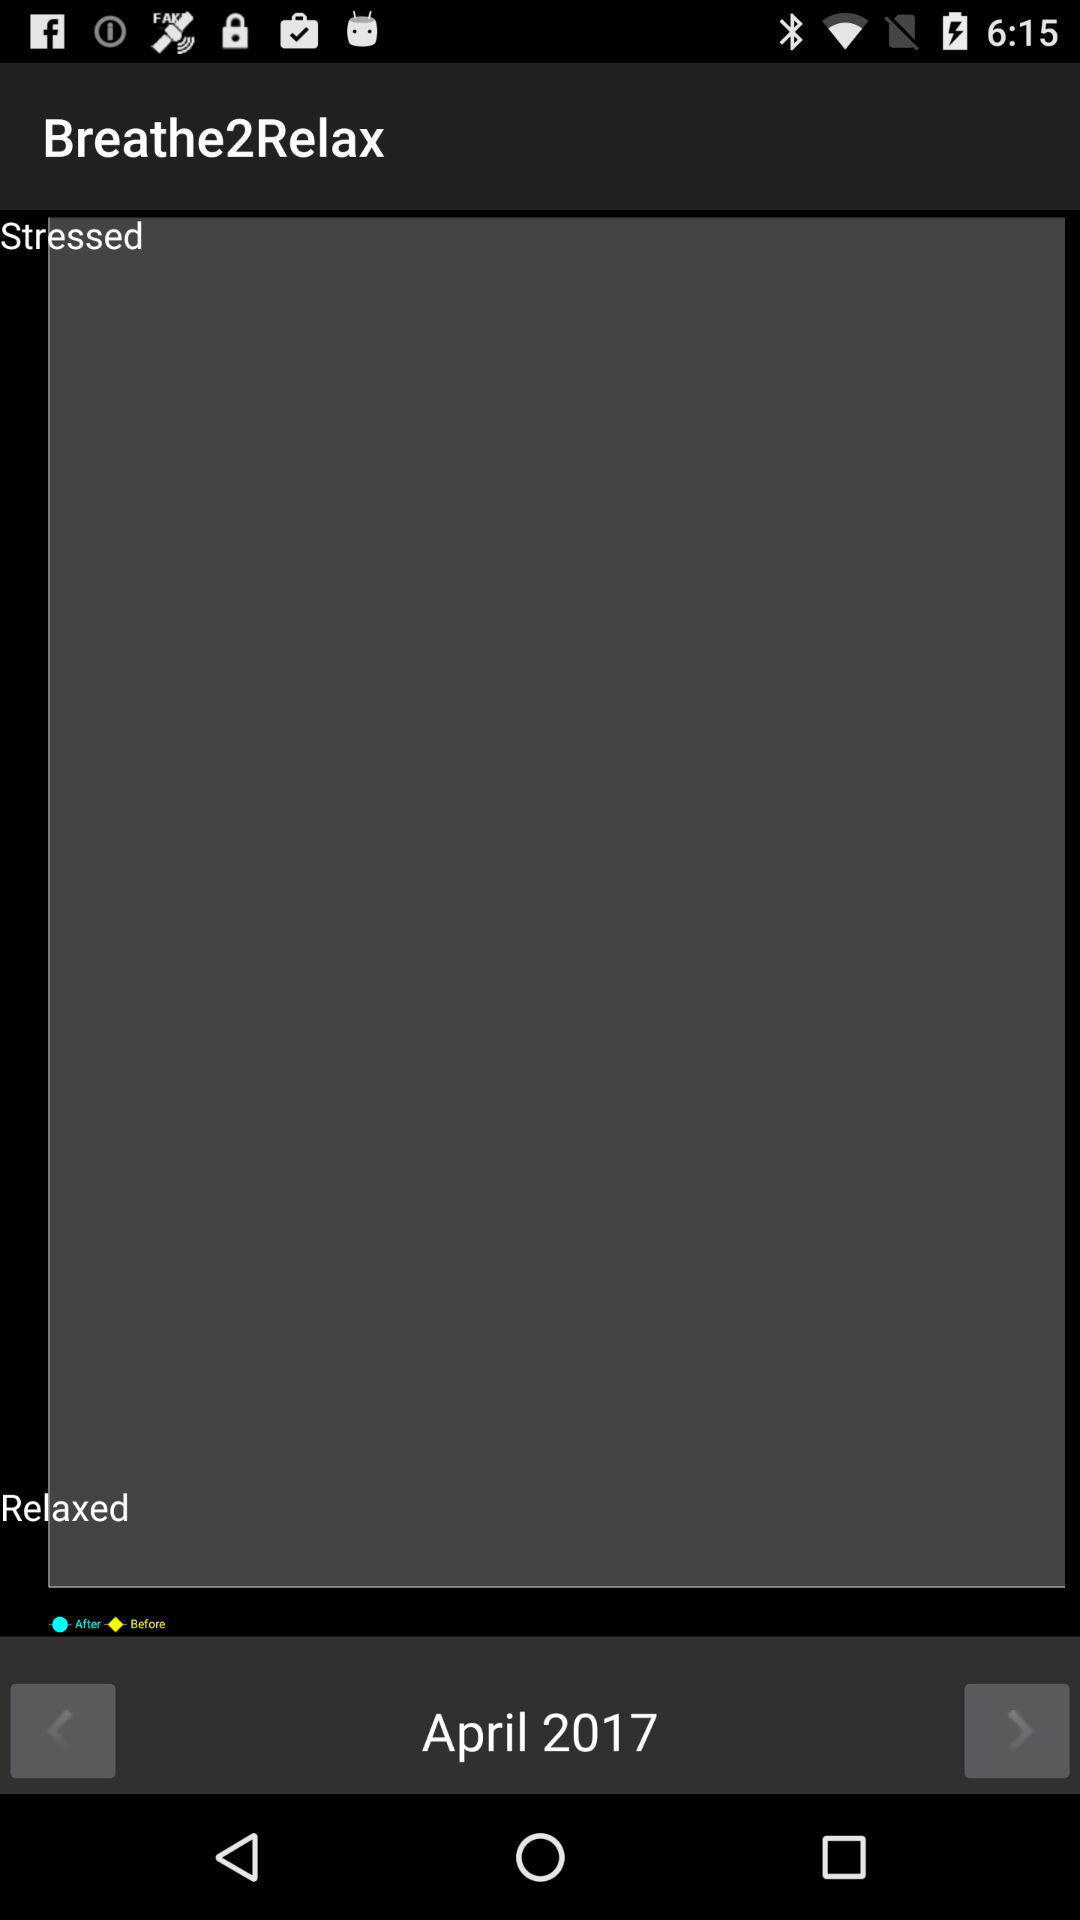What is the selected month and year? The selected month and year are April and 2017, respectively. 